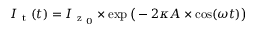Convert formula to latex. <formula><loc_0><loc_0><loc_500><loc_500>I _ { t } ( t ) = I _ { z _ { 0 } } \times \exp \left ( - 2 \kappa A \times \cos ( \omega t ) \right )</formula> 